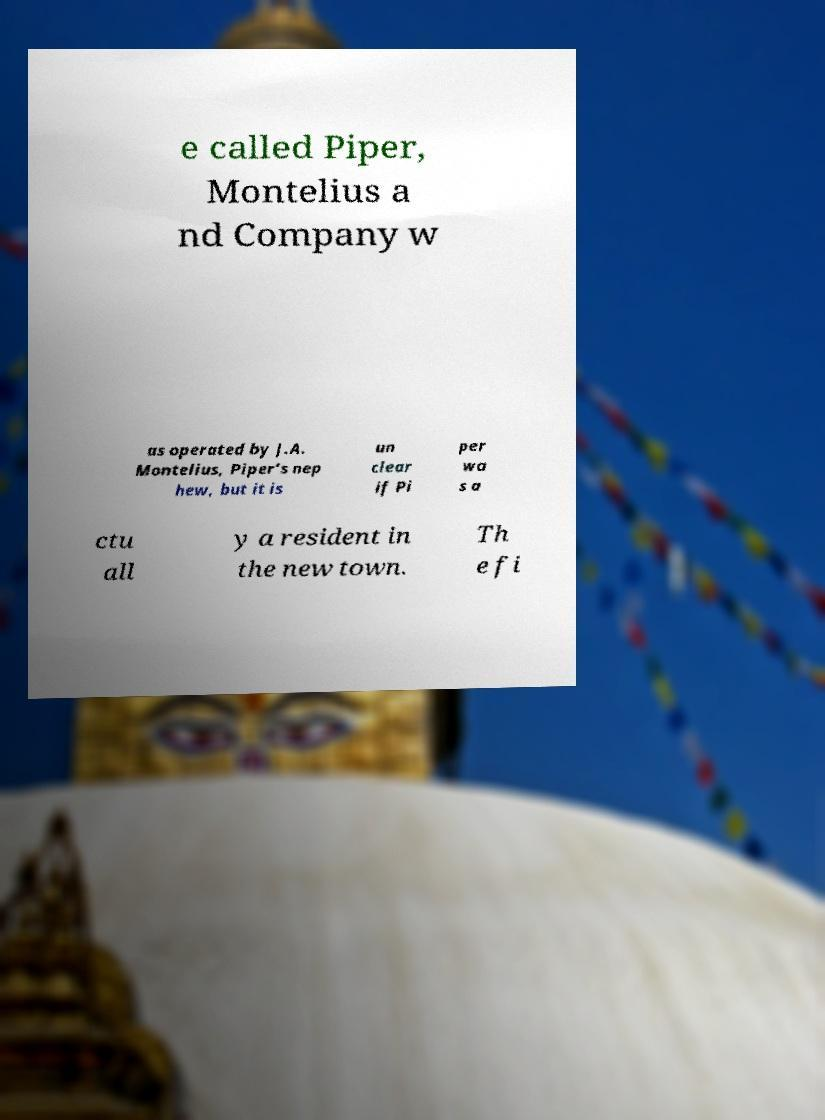There's text embedded in this image that I need extracted. Can you transcribe it verbatim? e called Piper, Montelius a nd Company w as operated by J.A. Montelius, Piper’s nep hew, but it is un clear if Pi per wa s a ctu all y a resident in the new town. Th e fi 